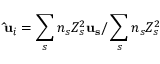<formula> <loc_0><loc_0><loc_500><loc_500>{ \hat { u } } _ { i } = \sum _ { s } n _ { s } Z _ { s } ^ { 2 } { u _ { s } } / \sum _ { s } n _ { s } Z _ { s } ^ { 2 }</formula> 